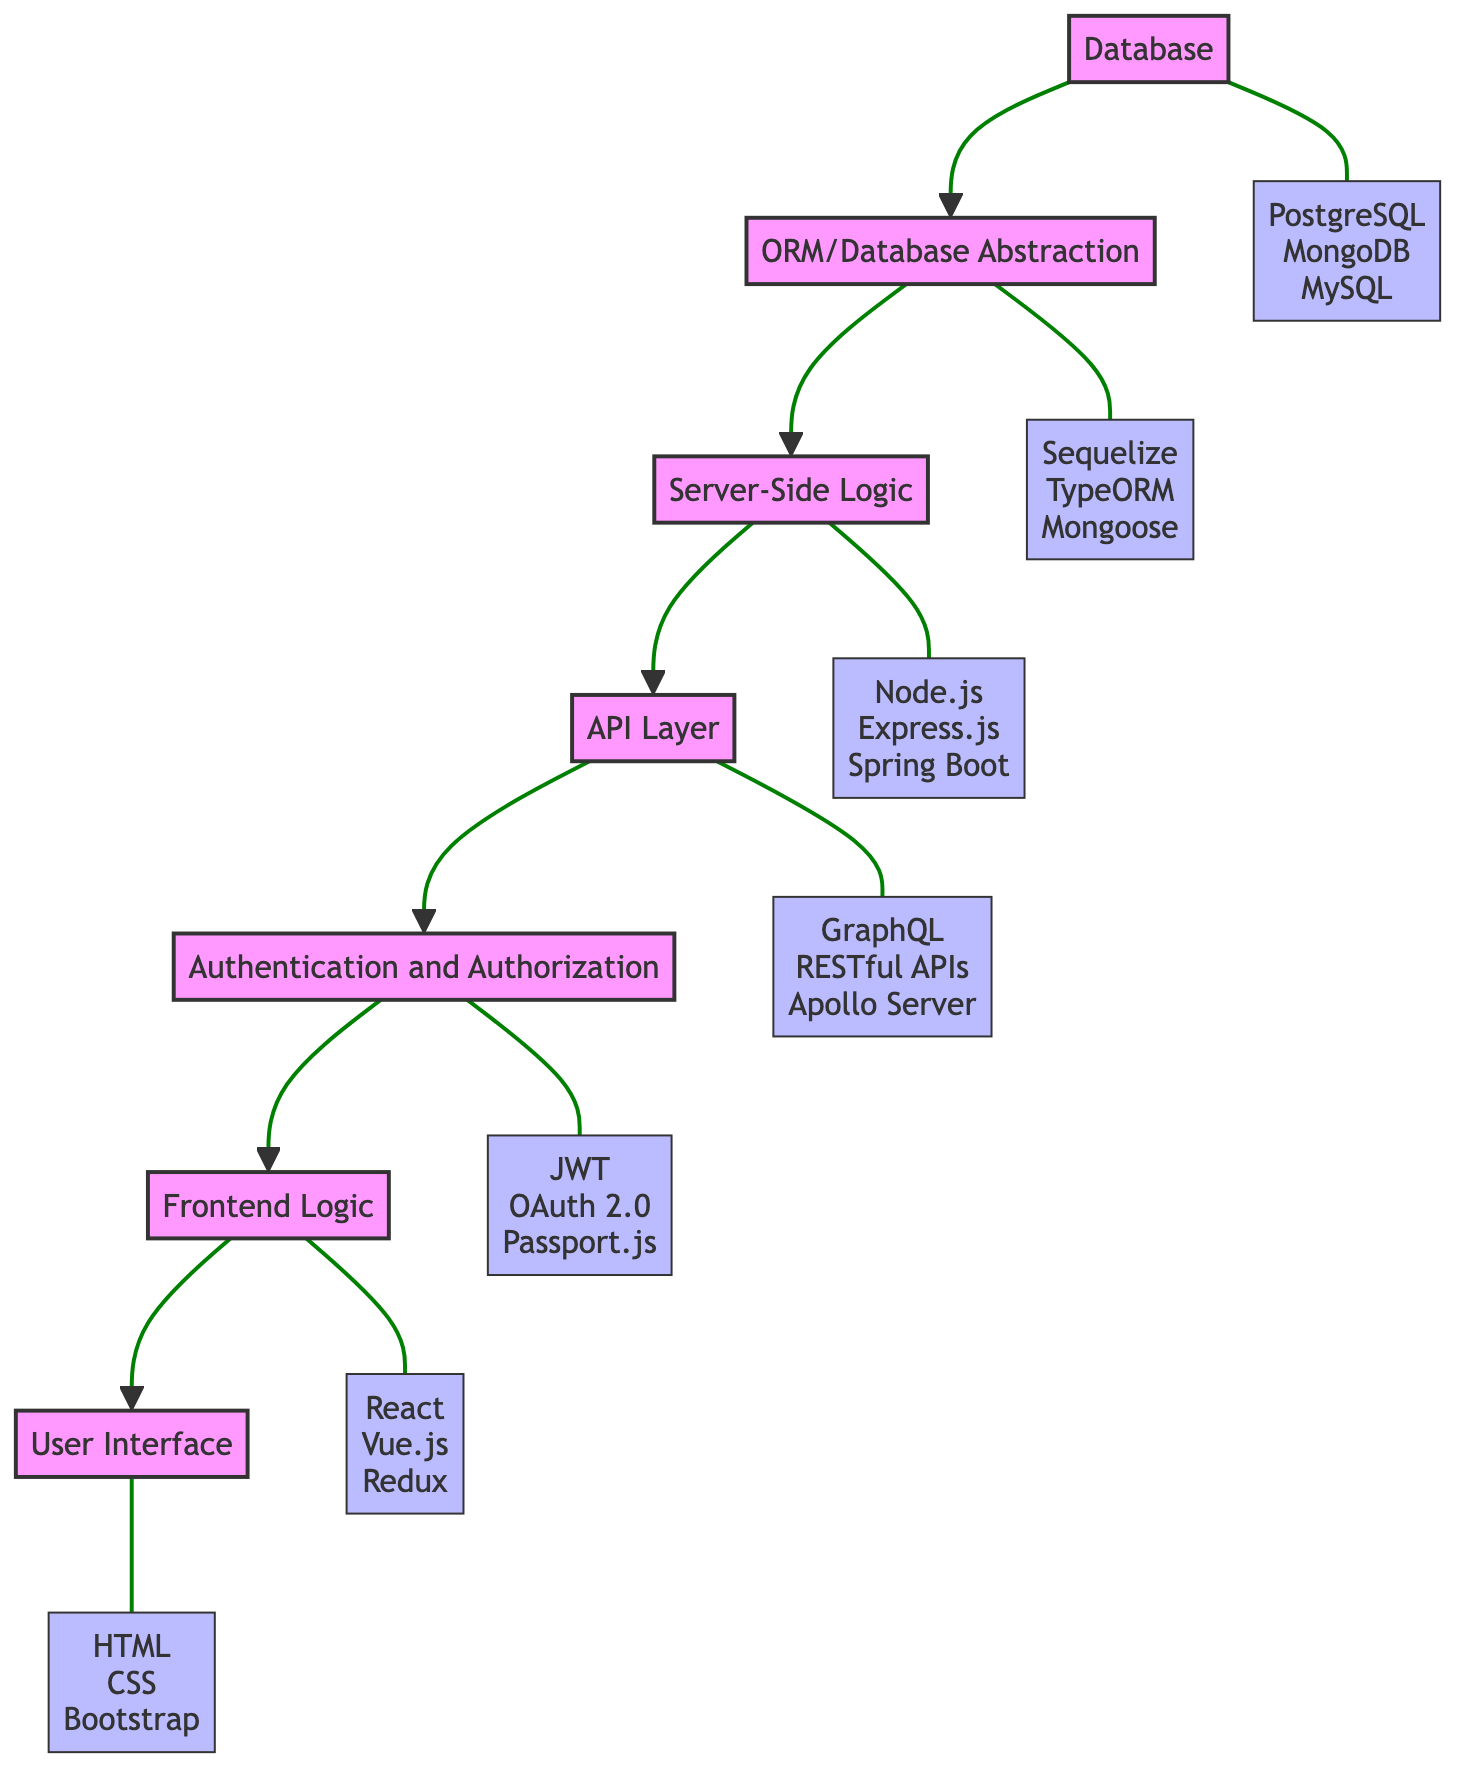What is at the bottom layer of the diagram? The diagram illustrates layers in a web application architecture. The bottom layer, which is the first in the flow from bottom to top, is labeled "Database."
Answer: Database How many tools are listed for the User Interface layer? The User Interface layer includes a list of three tools specified in the diagram: HTML, CSS, and Bootstrap. Thus, there are a total of three tools listed.
Answer: 3 What layer directly above the API Layer in the diagram? Observing the flow from bottom to top, the API Layer points upwards to the next layer, which is "Authentication and Authorization."
Answer: Authentication and Authorization Which layer is responsible for exposing server-side logic? The layer that exposes server-side logic is specifically labeled "API Layer," which is identified as the one that provides access to the backend functionalities through APIs.
Answer: API Layer Which tools are associated with the Frontend Logic layer? The Frontend Logic layer points towards the tools listed, which include React, Vue.js, and Redux. Thus, these three are the associated tools for Frontend Logic.
Answer: React, Vue.js, Redux Which layer deals with user authentication? In the flow, there is a designated layer called "Authentication and Authorization," which is specifically responsible for managing user authentication and access control.
Answer: Authentication and Authorization How many layers are represented in the diagram in total? By counting each layer from the Database to the User Interface, there are seven distinct layers shown in the diagram.
Answer: 7 What relationship do the ORM and Database layers have? The ORM layer is shown directly above the Database layer and receives input from it, indicating that the ORM utilizes data stored in the Database to provide abstraction for data access.
Answer: Stacked relationship Which tools are used for Database Abstraction? The tools associated with the ORM/Database Abstraction layer include Sequelize, TypeORM, and Mongoose as per the information in the diagram.
Answer: Sequelize, TypeORM, Mongoose 